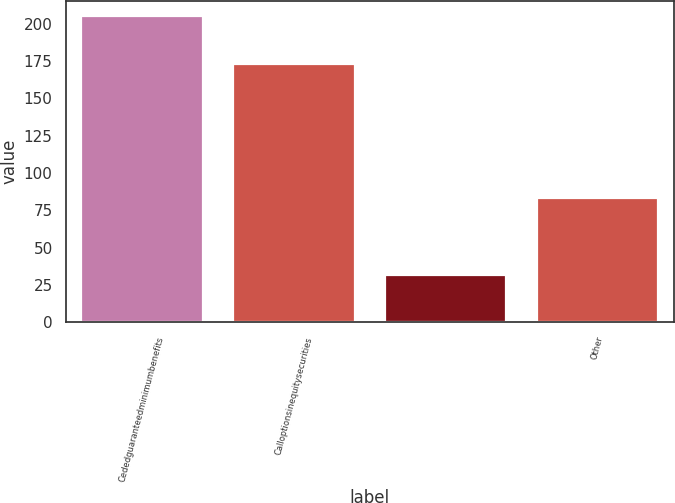Convert chart. <chart><loc_0><loc_0><loc_500><loc_500><bar_chart><fcel>Cededguaranteedminimumbenefits<fcel>Calloptionsinequitysecurities<fcel>Unnamed: 2<fcel>Other<nl><fcel>205<fcel>173<fcel>32<fcel>83<nl></chart> 